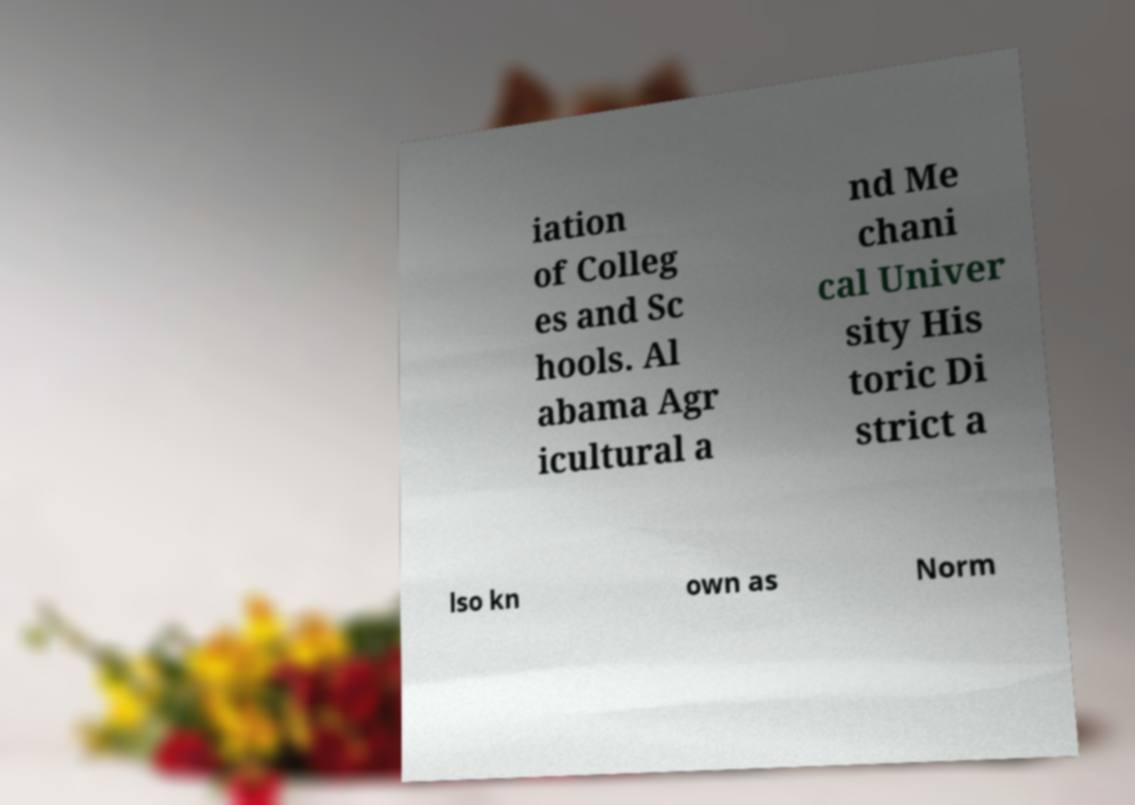There's text embedded in this image that I need extracted. Can you transcribe it verbatim? iation of Colleg es and Sc hools. Al abama Agr icultural a nd Me chani cal Univer sity His toric Di strict a lso kn own as Norm 